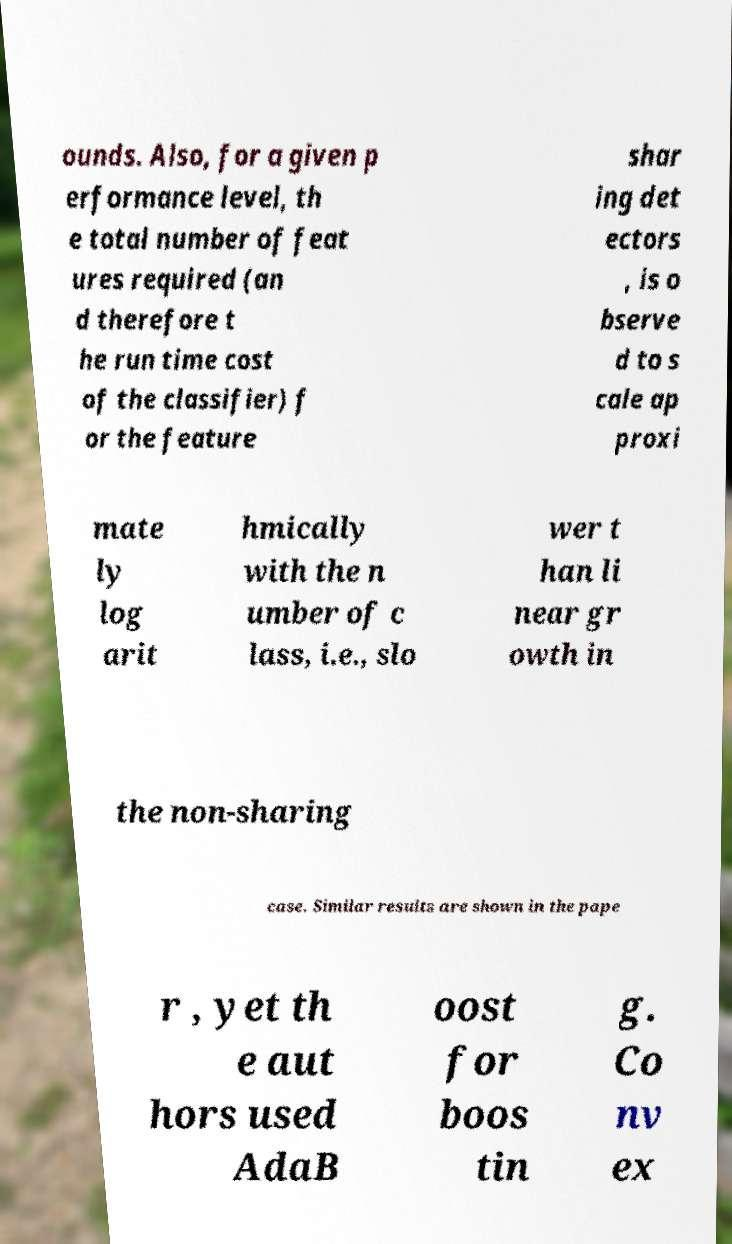There's text embedded in this image that I need extracted. Can you transcribe it verbatim? ounds. Also, for a given p erformance level, th e total number of feat ures required (an d therefore t he run time cost of the classifier) f or the feature shar ing det ectors , is o bserve d to s cale ap proxi mate ly log arit hmically with the n umber of c lass, i.e., slo wer t han li near gr owth in the non-sharing case. Similar results are shown in the pape r , yet th e aut hors used AdaB oost for boos tin g. Co nv ex 